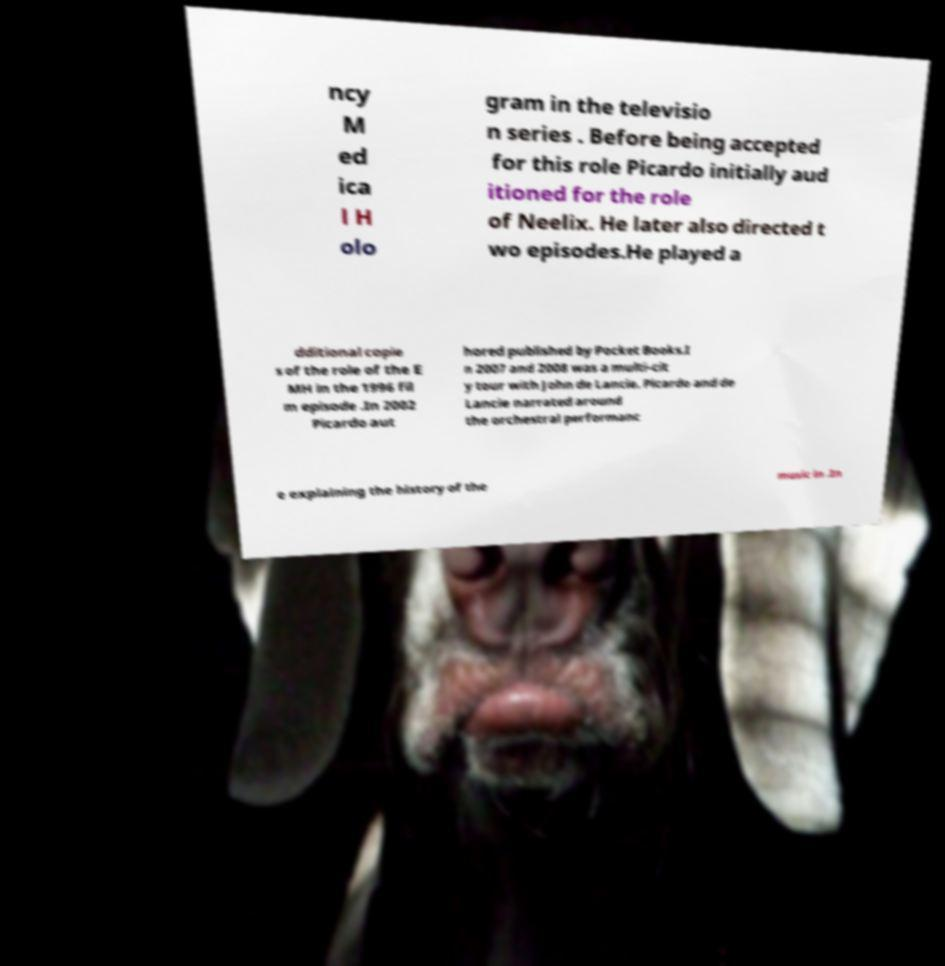Could you extract and type out the text from this image? ncy M ed ica l H olo gram in the televisio n series . Before being accepted for this role Picardo initially aud itioned for the role of Neelix. He later also directed t wo episodes.He played a dditional copie s of the role of the E MH in the 1996 fil m episode .In 2002 Picardo aut hored published by Pocket Books.I n 2007 and 2008 was a multi-cit y tour with John de Lancie. Picardo and de Lancie narrated around the orchestral performanc e explaining the history of the music in .In 